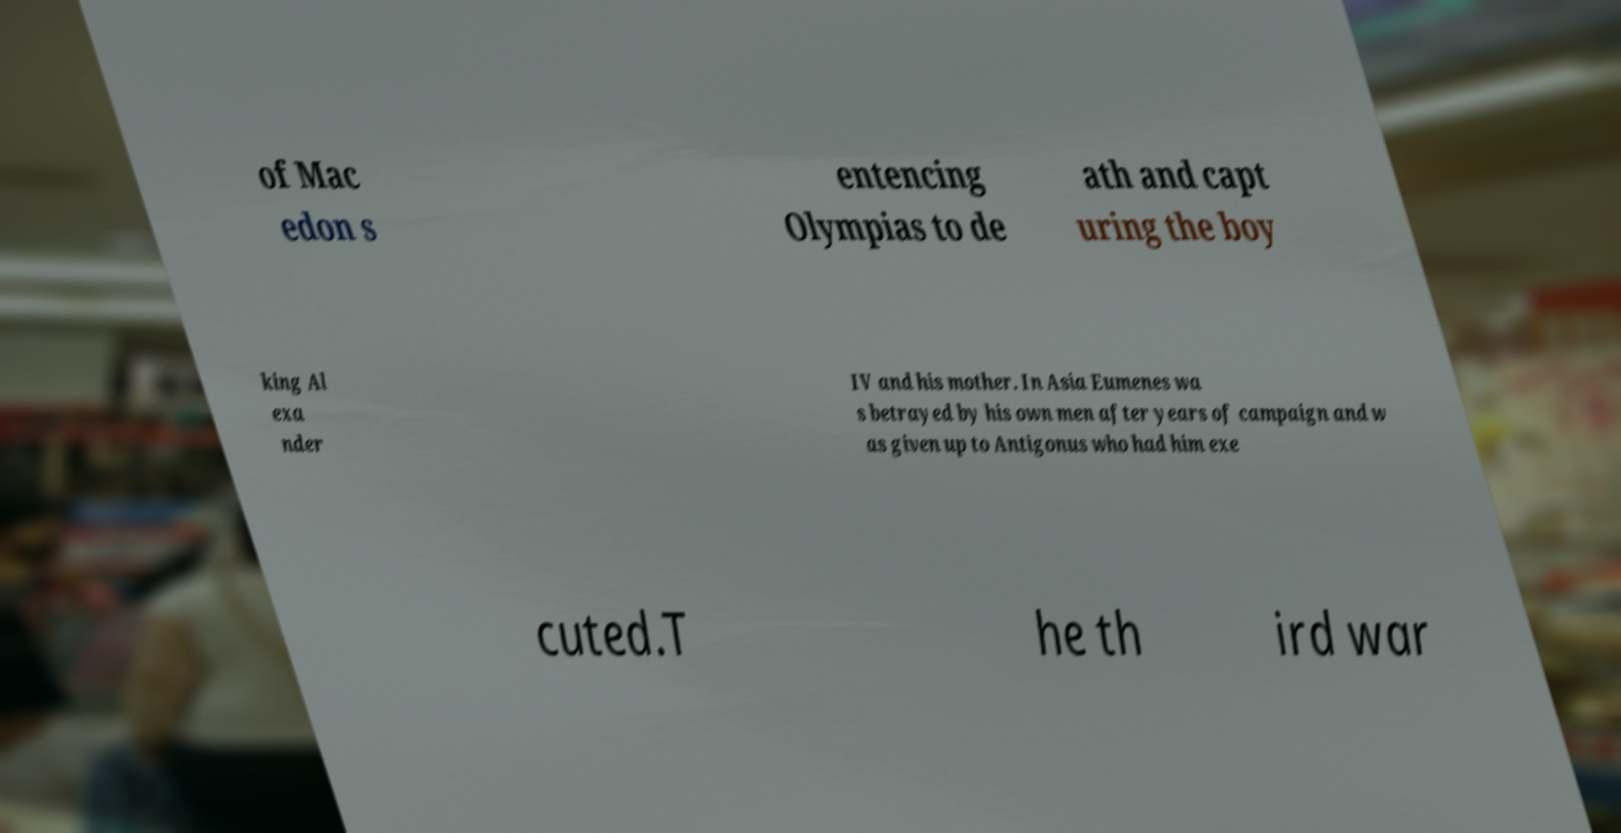Can you accurately transcribe the text from the provided image for me? of Mac edon s entencing Olympias to de ath and capt uring the boy king Al exa nder IV and his mother. In Asia Eumenes wa s betrayed by his own men after years of campaign and w as given up to Antigonus who had him exe cuted.T he th ird war 